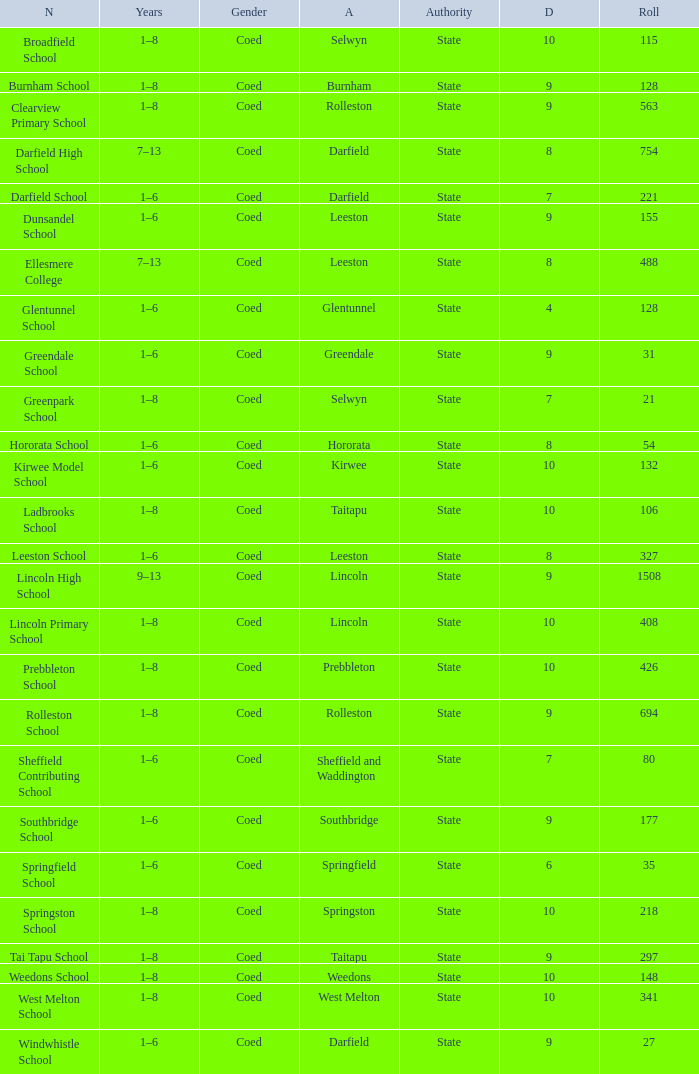Could you help me parse every detail presented in this table? {'header': ['N', 'Years', 'Gender', 'A', 'Authority', 'D', 'Roll'], 'rows': [['Broadfield School', '1–8', 'Coed', 'Selwyn', 'State', '10', '115'], ['Burnham School', '1–8', 'Coed', 'Burnham', 'State', '9', '128'], ['Clearview Primary School', '1–8', 'Coed', 'Rolleston', 'State', '9', '563'], ['Darfield High School', '7–13', 'Coed', 'Darfield', 'State', '8', '754'], ['Darfield School', '1–6', 'Coed', 'Darfield', 'State', '7', '221'], ['Dunsandel School', '1–6', 'Coed', 'Leeston', 'State', '9', '155'], ['Ellesmere College', '7–13', 'Coed', 'Leeston', 'State', '8', '488'], ['Glentunnel School', '1–6', 'Coed', 'Glentunnel', 'State', '4', '128'], ['Greendale School', '1–6', 'Coed', 'Greendale', 'State', '9', '31'], ['Greenpark School', '1–8', 'Coed', 'Selwyn', 'State', '7', '21'], ['Hororata School', '1–6', 'Coed', 'Hororata', 'State', '8', '54'], ['Kirwee Model School', '1–6', 'Coed', 'Kirwee', 'State', '10', '132'], ['Ladbrooks School', '1–8', 'Coed', 'Taitapu', 'State', '10', '106'], ['Leeston School', '1–6', 'Coed', 'Leeston', 'State', '8', '327'], ['Lincoln High School', '9–13', 'Coed', 'Lincoln', 'State', '9', '1508'], ['Lincoln Primary School', '1–8', 'Coed', 'Lincoln', 'State', '10', '408'], ['Prebbleton School', '1–8', 'Coed', 'Prebbleton', 'State', '10', '426'], ['Rolleston School', '1–8', 'Coed', 'Rolleston', 'State', '9', '694'], ['Sheffield Contributing School', '1–6', 'Coed', 'Sheffield and Waddington', 'State', '7', '80'], ['Southbridge School', '1–6', 'Coed', 'Southbridge', 'State', '9', '177'], ['Springfield School', '1–6', 'Coed', 'Springfield', 'State', '6', '35'], ['Springston School', '1–8', 'Coed', 'Springston', 'State', '10', '218'], ['Tai Tapu School', '1–8', 'Coed', 'Taitapu', 'State', '9', '297'], ['Weedons School', '1–8', 'Coed', 'Weedons', 'State', '10', '148'], ['West Melton School', '1–8', 'Coed', 'West Melton', 'State', '10', '341'], ['Windwhistle School', '1–6', 'Coed', 'Darfield', 'State', '9', '27']]} What is the name with a Decile less than 10, and a Roll of 297? Tai Tapu School. 